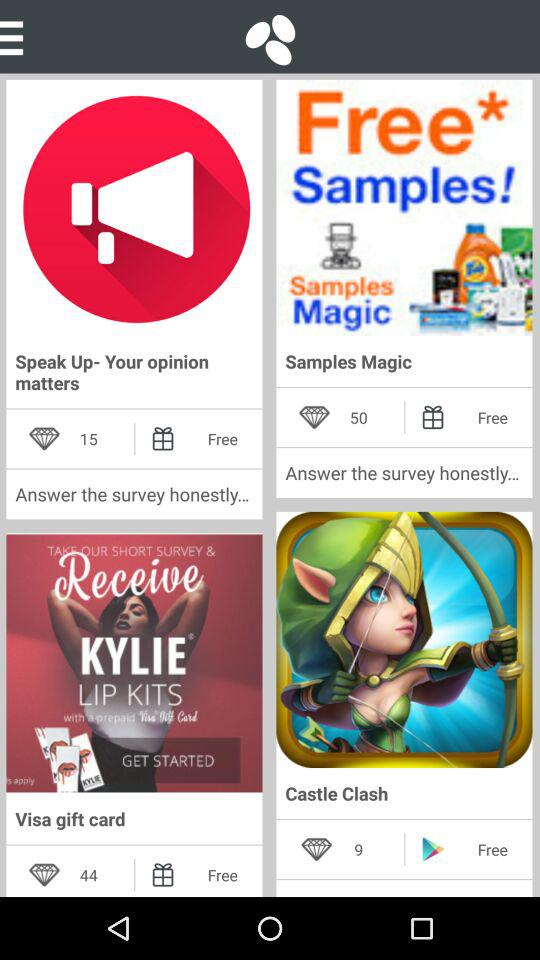How many diamonds does Castle Clash get? In Castle Clash,one gets 9 diamonds. 